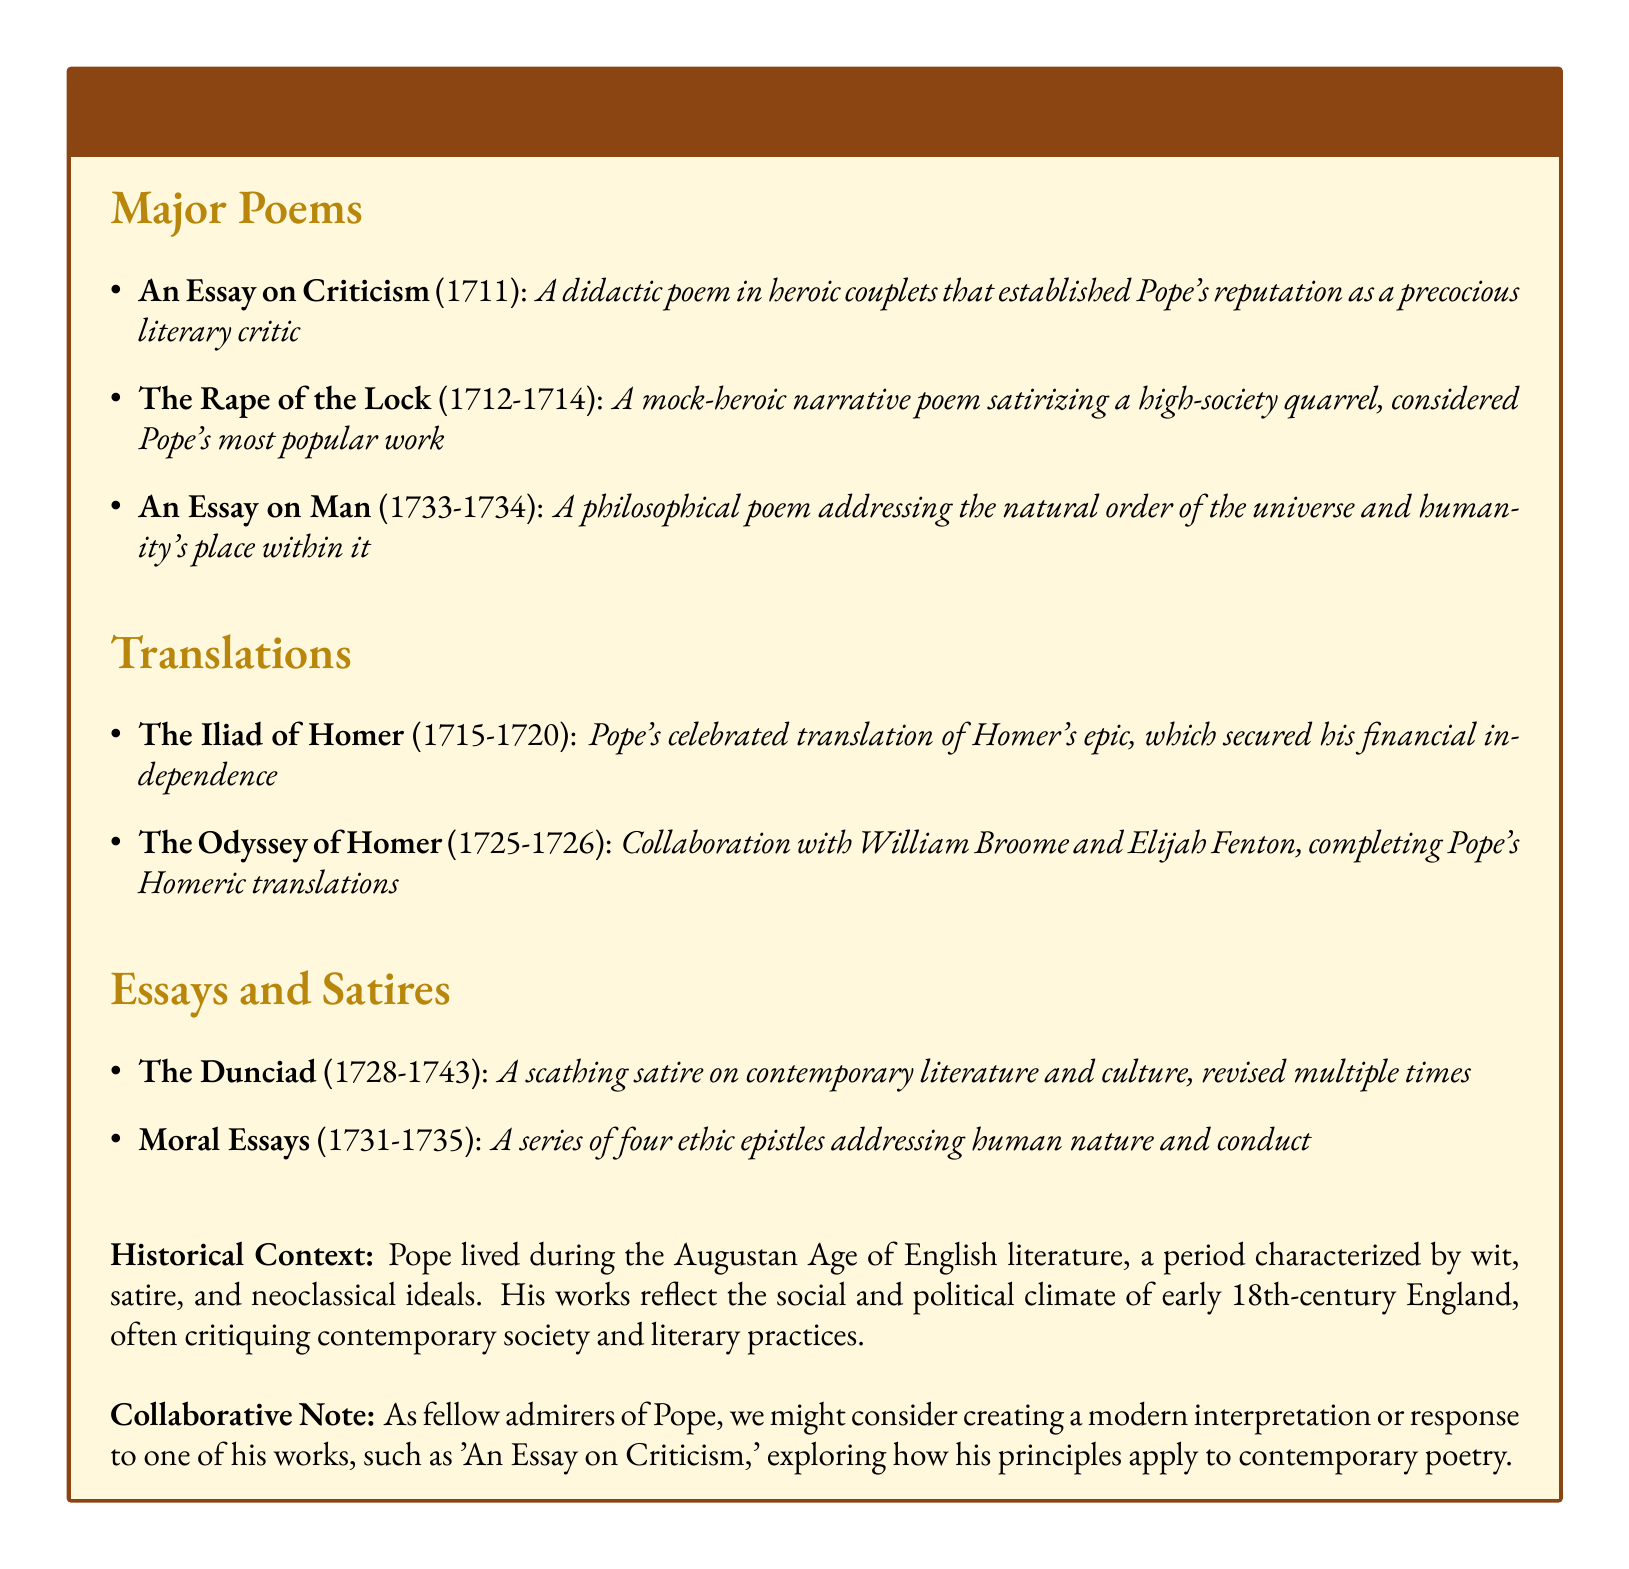What year was "An Essay on Criticism" published? The publication year is explicitly mentioned in the document next to the title of the poem.
Answer: 1711 How many major poems are listed in the catalog? The total number of major poems is found by counting the list under the Major Poems section.
Answer: 3 What is the subtitle of "The Rape of the Lock"? The subtitle can be derived from the description provided for "The Rape of the Lock".
Answer: A mock-heroic narrative poem Who collaborated with Pope on "The Odyssey of Homer"? The document specifies the collaborators in the translation section.
Answer: William Broome and Elijah Fenton In what years was "The Dunciad" revised? The years during which "The Dunciad" was revised are clearly stated in the description.
Answer: 1728-1743 What philosophical themes does "An Essay on Man" address? The theme is directly described in the context of the poem in the document.
Answer: The natural order of the universe How many ethic epistles are in "Moral Essays"? The document mentions the number in the description under the Essays and Satires section.
Answer: Four What literary period did Alexander Pope's works reflect? The relevant period is mentioned in the Historical Context section of the document.
Answer: Augustan Age What form does "An Essay on Criticism" use? The form used is noted in the description of the poem.
Answer: Heroic couplets 